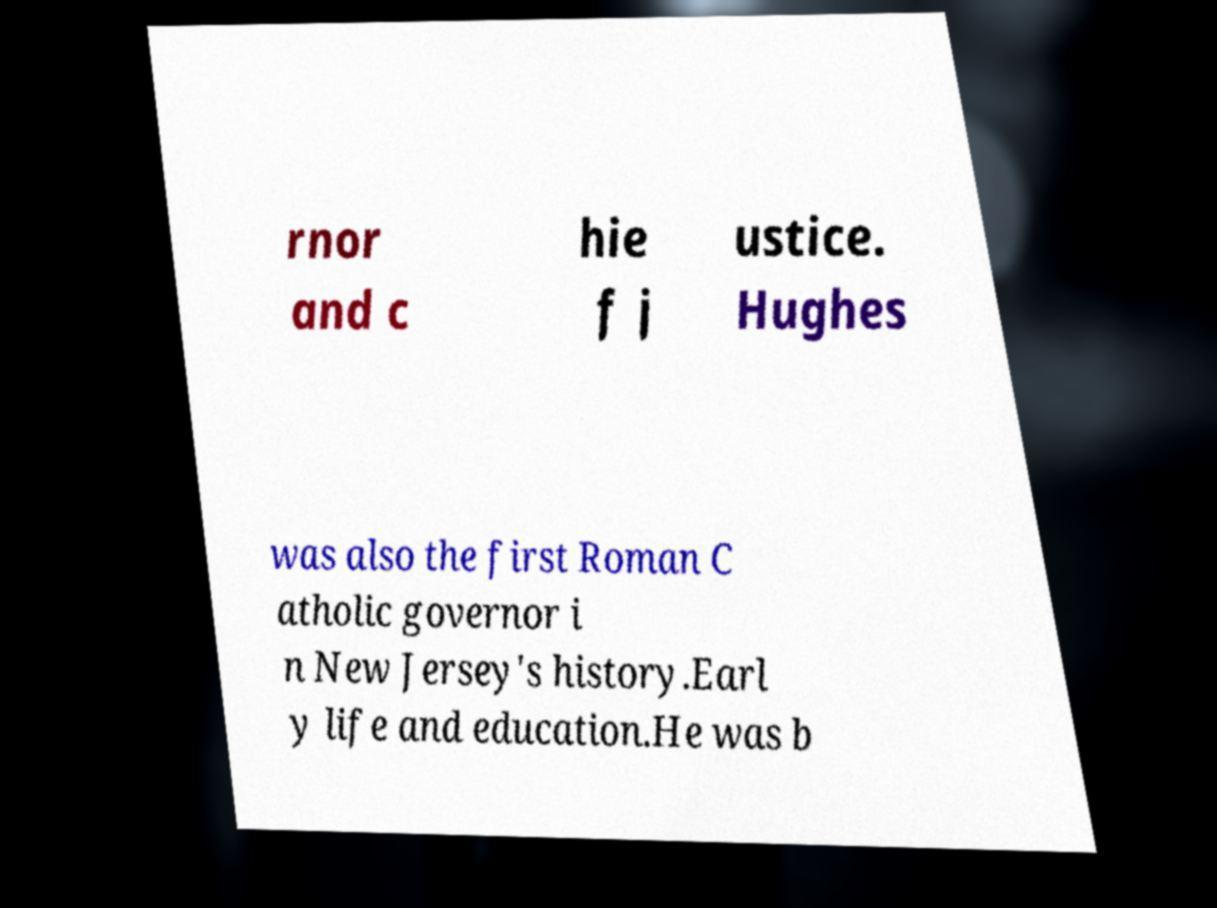Please identify and transcribe the text found in this image. rnor and c hie f j ustice. Hughes was also the first Roman C atholic governor i n New Jersey's history.Earl y life and education.He was b 